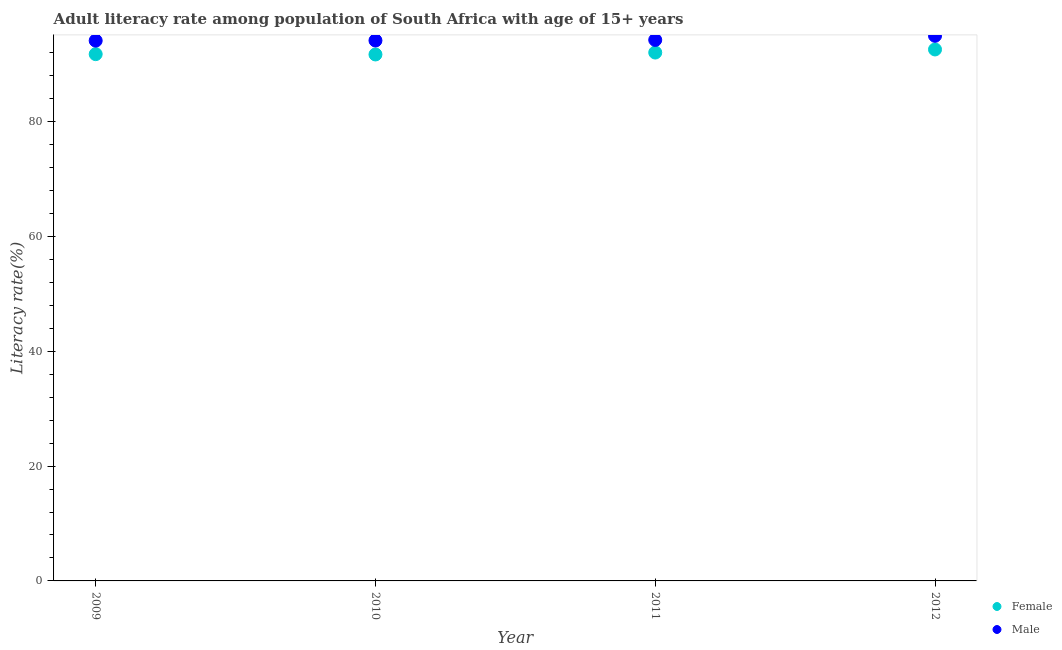How many different coloured dotlines are there?
Ensure brevity in your answer.  2. Is the number of dotlines equal to the number of legend labels?
Make the answer very short. Yes. What is the female adult literacy rate in 2011?
Your answer should be compact. 92.05. Across all years, what is the maximum male adult literacy rate?
Provide a succinct answer. 94.96. Across all years, what is the minimum female adult literacy rate?
Give a very brief answer. 91.71. In which year was the male adult literacy rate maximum?
Make the answer very short. 2012. What is the total female adult literacy rate in the graph?
Make the answer very short. 368.12. What is the difference between the female adult literacy rate in 2009 and that in 2010?
Provide a succinct answer. 0.05. What is the difference between the male adult literacy rate in 2010 and the female adult literacy rate in 2009?
Give a very brief answer. 2.38. What is the average female adult literacy rate per year?
Provide a short and direct response. 92.03. In the year 2011, what is the difference between the female adult literacy rate and male adult literacy rate?
Give a very brief answer. -2.2. In how many years, is the female adult literacy rate greater than 60 %?
Ensure brevity in your answer.  4. What is the ratio of the male adult literacy rate in 2011 to that in 2012?
Offer a very short reply. 0.99. Is the male adult literacy rate in 2011 less than that in 2012?
Give a very brief answer. Yes. Is the difference between the male adult literacy rate in 2009 and 2012 greater than the difference between the female adult literacy rate in 2009 and 2012?
Provide a succinct answer. No. What is the difference between the highest and the second highest female adult literacy rate?
Ensure brevity in your answer.  0.54. What is the difference between the highest and the lowest male adult literacy rate?
Offer a terse response. 0.84. Is the sum of the female adult literacy rate in 2009 and 2012 greater than the maximum male adult literacy rate across all years?
Offer a terse response. Yes. Is the female adult literacy rate strictly greater than the male adult literacy rate over the years?
Make the answer very short. No. How many dotlines are there?
Ensure brevity in your answer.  2. How many years are there in the graph?
Your answer should be compact. 4. Where does the legend appear in the graph?
Ensure brevity in your answer.  Bottom right. What is the title of the graph?
Give a very brief answer. Adult literacy rate among population of South Africa with age of 15+ years. Does "Depositors" appear as one of the legend labels in the graph?
Your answer should be compact. No. What is the label or title of the X-axis?
Provide a short and direct response. Year. What is the label or title of the Y-axis?
Your response must be concise. Literacy rate(%). What is the Literacy rate(%) of Female in 2009?
Offer a terse response. 91.77. What is the Literacy rate(%) of Male in 2009?
Your answer should be very brief. 94.12. What is the Literacy rate(%) in Female in 2010?
Your answer should be compact. 91.71. What is the Literacy rate(%) of Male in 2010?
Give a very brief answer. 94.14. What is the Literacy rate(%) in Female in 2011?
Your response must be concise. 92.05. What is the Literacy rate(%) in Male in 2011?
Your answer should be compact. 94.25. What is the Literacy rate(%) in Female in 2012?
Keep it short and to the point. 92.59. What is the Literacy rate(%) in Male in 2012?
Give a very brief answer. 94.96. Across all years, what is the maximum Literacy rate(%) of Female?
Ensure brevity in your answer.  92.59. Across all years, what is the maximum Literacy rate(%) of Male?
Provide a short and direct response. 94.96. Across all years, what is the minimum Literacy rate(%) in Female?
Provide a succinct answer. 91.71. Across all years, what is the minimum Literacy rate(%) in Male?
Your answer should be compact. 94.12. What is the total Literacy rate(%) of Female in the graph?
Offer a very short reply. 368.12. What is the total Literacy rate(%) of Male in the graph?
Provide a short and direct response. 377.47. What is the difference between the Literacy rate(%) of Female in 2009 and that in 2010?
Provide a short and direct response. 0.05. What is the difference between the Literacy rate(%) of Male in 2009 and that in 2010?
Your answer should be compact. -0.02. What is the difference between the Literacy rate(%) in Female in 2009 and that in 2011?
Make the answer very short. -0.28. What is the difference between the Literacy rate(%) of Male in 2009 and that in 2011?
Provide a short and direct response. -0.12. What is the difference between the Literacy rate(%) of Female in 2009 and that in 2012?
Your answer should be compact. -0.82. What is the difference between the Literacy rate(%) of Male in 2009 and that in 2012?
Ensure brevity in your answer.  -0.84. What is the difference between the Literacy rate(%) of Female in 2010 and that in 2011?
Your answer should be very brief. -0.33. What is the difference between the Literacy rate(%) of Male in 2010 and that in 2011?
Your answer should be compact. -0.1. What is the difference between the Literacy rate(%) in Female in 2010 and that in 2012?
Ensure brevity in your answer.  -0.87. What is the difference between the Literacy rate(%) of Male in 2010 and that in 2012?
Make the answer very short. -0.82. What is the difference between the Literacy rate(%) in Female in 2011 and that in 2012?
Provide a short and direct response. -0.54. What is the difference between the Literacy rate(%) in Male in 2011 and that in 2012?
Your answer should be very brief. -0.72. What is the difference between the Literacy rate(%) in Female in 2009 and the Literacy rate(%) in Male in 2010?
Provide a succinct answer. -2.38. What is the difference between the Literacy rate(%) of Female in 2009 and the Literacy rate(%) of Male in 2011?
Your answer should be very brief. -2.48. What is the difference between the Literacy rate(%) in Female in 2009 and the Literacy rate(%) in Male in 2012?
Your response must be concise. -3.2. What is the difference between the Literacy rate(%) of Female in 2010 and the Literacy rate(%) of Male in 2011?
Your answer should be compact. -2.53. What is the difference between the Literacy rate(%) in Female in 2010 and the Literacy rate(%) in Male in 2012?
Your answer should be very brief. -3.25. What is the difference between the Literacy rate(%) of Female in 2011 and the Literacy rate(%) of Male in 2012?
Make the answer very short. -2.92. What is the average Literacy rate(%) of Female per year?
Provide a succinct answer. 92.03. What is the average Literacy rate(%) of Male per year?
Give a very brief answer. 94.37. In the year 2009, what is the difference between the Literacy rate(%) in Female and Literacy rate(%) in Male?
Provide a succinct answer. -2.35. In the year 2010, what is the difference between the Literacy rate(%) of Female and Literacy rate(%) of Male?
Offer a terse response. -2.43. In the year 2011, what is the difference between the Literacy rate(%) in Female and Literacy rate(%) in Male?
Keep it short and to the point. -2.2. In the year 2012, what is the difference between the Literacy rate(%) of Female and Literacy rate(%) of Male?
Provide a short and direct response. -2.38. What is the ratio of the Literacy rate(%) in Female in 2009 to that in 2010?
Offer a very short reply. 1. What is the ratio of the Literacy rate(%) of Male in 2009 to that in 2010?
Provide a short and direct response. 1. What is the ratio of the Literacy rate(%) in Female in 2009 to that in 2011?
Provide a short and direct response. 1. What is the ratio of the Literacy rate(%) of Male in 2009 to that in 2011?
Offer a terse response. 1. What is the ratio of the Literacy rate(%) of Female in 2010 to that in 2011?
Make the answer very short. 1. What is the ratio of the Literacy rate(%) of Female in 2010 to that in 2012?
Offer a terse response. 0.99. What is the ratio of the Literacy rate(%) of Female in 2011 to that in 2012?
Make the answer very short. 0.99. What is the difference between the highest and the second highest Literacy rate(%) of Female?
Your response must be concise. 0.54. What is the difference between the highest and the second highest Literacy rate(%) of Male?
Provide a succinct answer. 0.72. What is the difference between the highest and the lowest Literacy rate(%) in Female?
Offer a terse response. 0.87. What is the difference between the highest and the lowest Literacy rate(%) in Male?
Give a very brief answer. 0.84. 